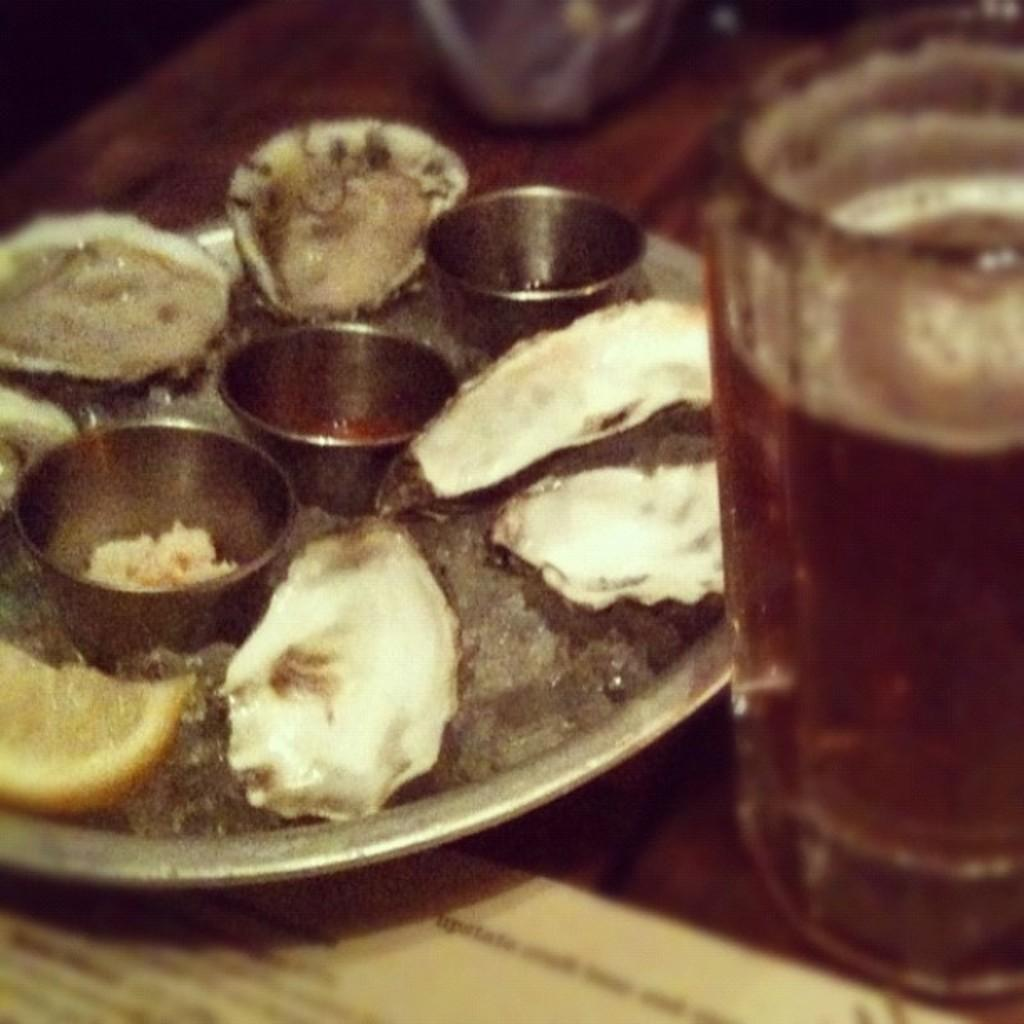What piece of furniture is present in the image? There is a table in the image. What is placed on the table? There is a plate on the table, and it contains food. Are there any other containers on the table? Yes, there are small bowls on the table. What might be used for drinking in the image? There is a glass on the table. What type of item is made of paper in the image? There is a paper in the image. What type of celery is growing out of the glass in the image? There is no celery present in the image, and it is not growing out of the glass. 